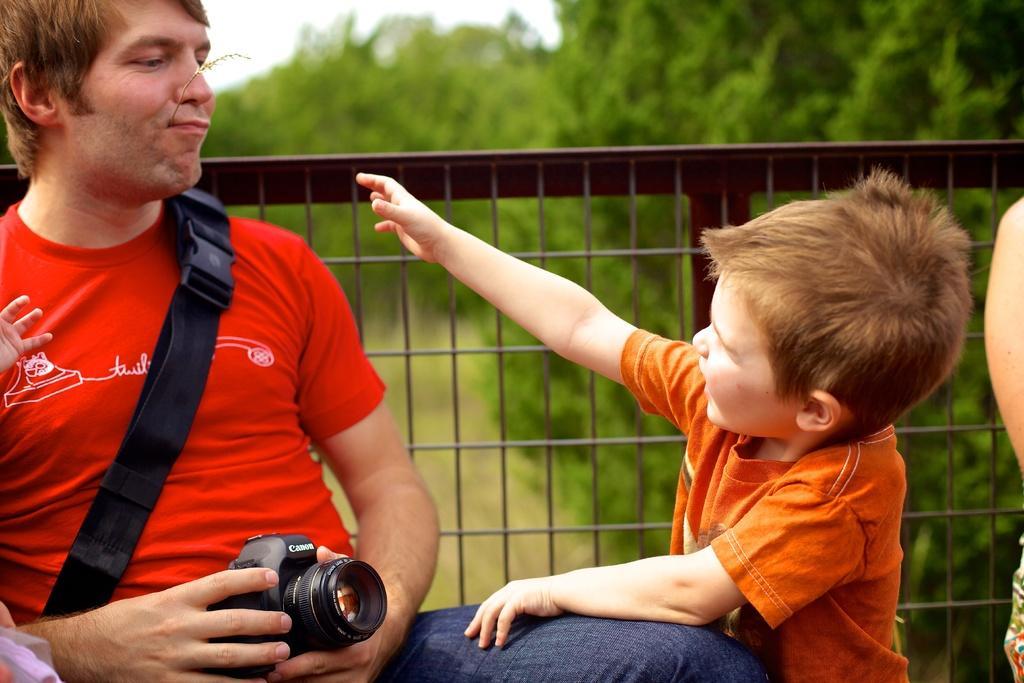How would you summarize this image in a sentence or two? In this image, we can see few peoples. The boy is wearing a orange color t-shirt. Left side, a man is holding camera on his hand. And here we can see belt and fencing. The background, there are so many trees. 